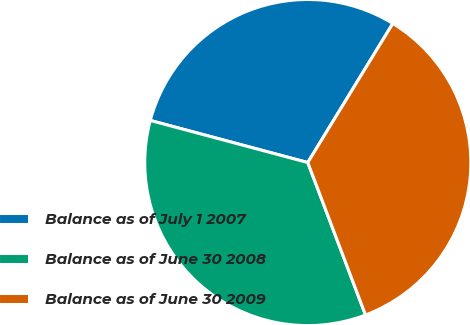Convert chart. <chart><loc_0><loc_0><loc_500><loc_500><pie_chart><fcel>Balance as of July 1 2007<fcel>Balance as of June 30 2008<fcel>Balance as of June 30 2009<nl><fcel>29.58%<fcel>34.92%<fcel>35.5%<nl></chart> 